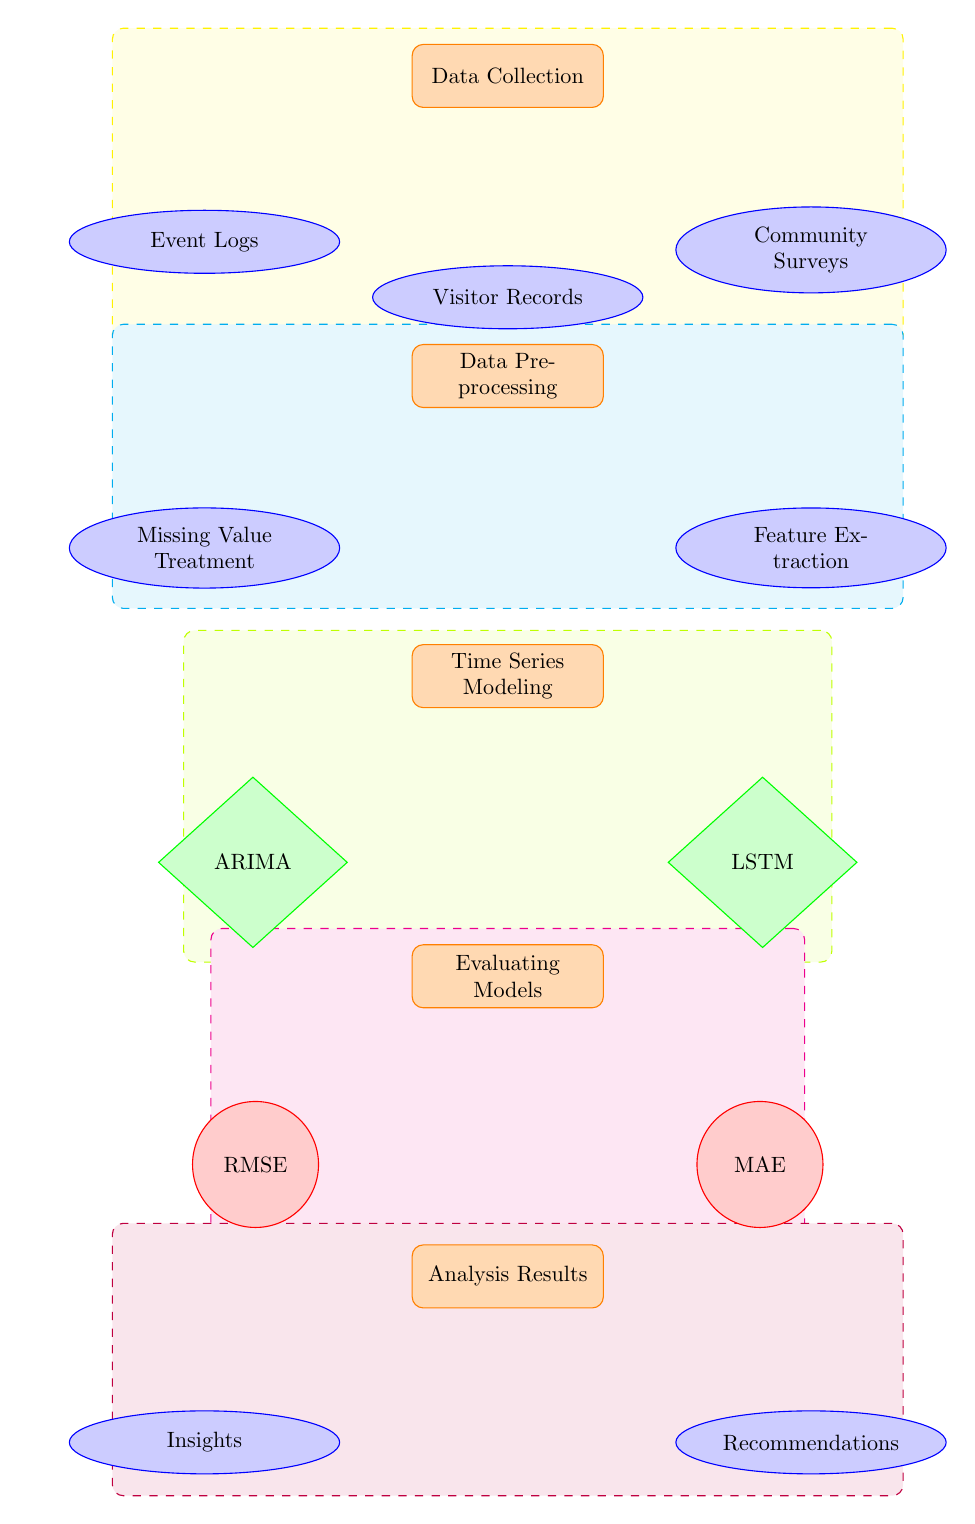What are the three types of data collected in the first stage? The diagram shows three types of data: Event Logs, Visitor Records, and Community Surveys, which are all stemming from the Data Collection process.
Answer: Event Logs, Visitor Records, Community Surveys How many processes are shown in the diagram? By counting all the unique rectangular nodes in the diagram, we find there are five processes: Data Collection, Data Preprocessing, Time Series Modeling, Evaluating Models, and Analysis Results.
Answer: 5 What is the output of the Time Series Modeling process? The two models being applied within the Time Series Modeling process are ARIMA and LSTM, as indicated by the arrows pointing from Time Series Modeling.
Answer: ARIMA, LSTM Which process comes before Data Preprocessing? Observing the diagram, it is clear that Data Collection is the process directly above Data Preprocessing, indicated by the flow of arrows.
Answer: Data Collection What are the two metrics used for Evaluating Models? The diagram indicates that RMSE and MAE are the two metrics used for evaluation, as depicted in the circular nodes below the Evaluating Models process.
Answer: RMSE, MAE How many nodes are involved in analyzing results? Looking at the Analysis Results process, there are two output nodes: Insights and Recommendations, indicating two nodes are involved in the analysis.
Answer: 2 What type of model is represented in the lower left below Time Series Modeling? The lower left node under Time Series Modeling is labeled ARIMA, which identifies it as a specific type of statistical forecast model.
Answer: ARIMA What follows the Evaluating Models process in the workflow? According to the diagram, the process that follows Evaluating Models is Analysis Results, as indicated by the connecting arrow from the Evaluating Models node.
Answer: Analysis Results What is the purpose of the Data Preprocessing stage? The Data Preprocessing stage aims to treat missing values and extract relevant features, as indicated by the related nodes below this stage.
Answer: Missing Value Treatment, Feature Extraction 